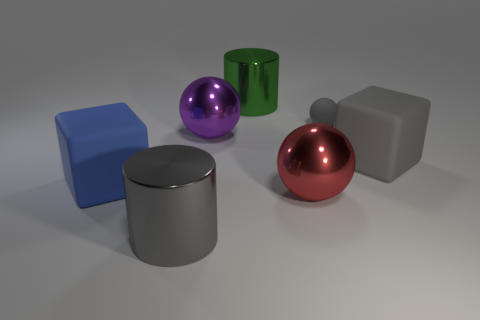Add 2 big yellow rubber cylinders. How many objects exist? 9 Subtract all metal spheres. How many spheres are left? 1 Subtract all gray spheres. How many spheres are left? 2 Subtract all blocks. How many objects are left? 5 Subtract 2 cubes. How many cubes are left? 0 Subtract all yellow blocks. How many purple balls are left? 1 Subtract 0 brown spheres. How many objects are left? 7 Subtract all cyan spheres. Subtract all green cubes. How many spheres are left? 3 Subtract all small blue metallic blocks. Subtract all matte cubes. How many objects are left? 5 Add 1 metallic cylinders. How many metallic cylinders are left? 3 